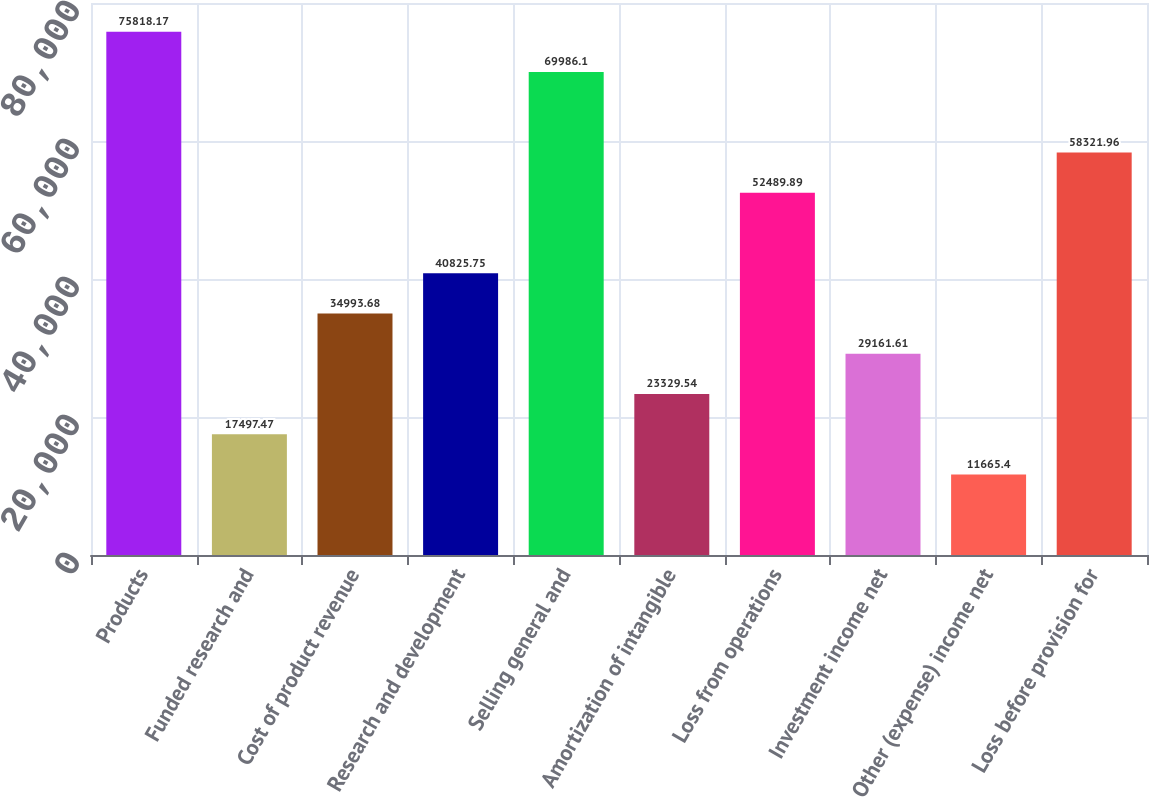Convert chart to OTSL. <chart><loc_0><loc_0><loc_500><loc_500><bar_chart><fcel>Products<fcel>Funded research and<fcel>Cost of product revenue<fcel>Research and development<fcel>Selling general and<fcel>Amortization of intangible<fcel>Loss from operations<fcel>Investment income net<fcel>Other (expense) income net<fcel>Loss before provision for<nl><fcel>75818.2<fcel>17497.5<fcel>34993.7<fcel>40825.8<fcel>69986.1<fcel>23329.5<fcel>52489.9<fcel>29161.6<fcel>11665.4<fcel>58322<nl></chart> 